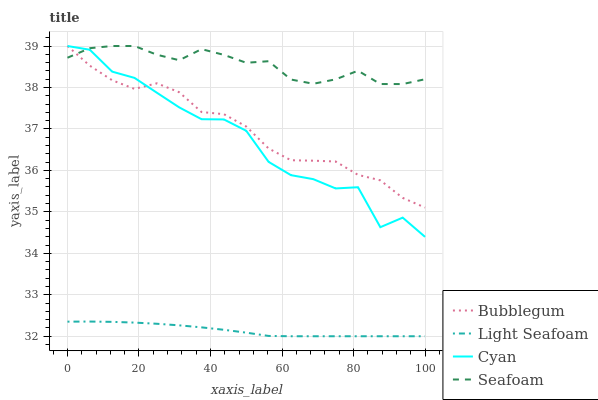Does Light Seafoam have the minimum area under the curve?
Answer yes or no. Yes. Does Seafoam have the maximum area under the curve?
Answer yes or no. Yes. Does Seafoam have the minimum area under the curve?
Answer yes or no. No. Does Light Seafoam have the maximum area under the curve?
Answer yes or no. No. Is Light Seafoam the smoothest?
Answer yes or no. Yes. Is Cyan the roughest?
Answer yes or no. Yes. Is Seafoam the smoothest?
Answer yes or no. No. Is Seafoam the roughest?
Answer yes or no. No. Does Light Seafoam have the lowest value?
Answer yes or no. Yes. Does Seafoam have the lowest value?
Answer yes or no. No. Does Bubblegum have the highest value?
Answer yes or no. Yes. Does Light Seafoam have the highest value?
Answer yes or no. No. Is Light Seafoam less than Bubblegum?
Answer yes or no. Yes. Is Cyan greater than Light Seafoam?
Answer yes or no. Yes. Does Bubblegum intersect Cyan?
Answer yes or no. Yes. Is Bubblegum less than Cyan?
Answer yes or no. No. Is Bubblegum greater than Cyan?
Answer yes or no. No. Does Light Seafoam intersect Bubblegum?
Answer yes or no. No. 